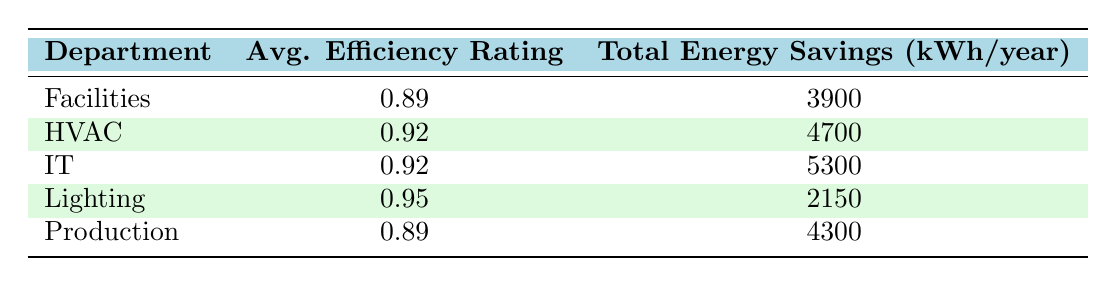What is the average efficiency rating for the HVAC department? According to the table, the average efficiency rating for the HVAC department is 0.92.
Answer: 0.92 Which department has the highest total energy savings? The IT department has the highest total energy savings at 5300 kWh/year.
Answer: IT What is the total energy savings for the Facilities department? The Facilities department has a total energy saving of 3900 kWh/year as stated in the table.
Answer: 3900 Is the average efficiency rating for the Production department greater than 0.90? No, the average efficiency rating for the Production department is 0.89, which is not greater than 0.90.
Answer: No If we combine the total energy savings from the IT and HVAC departments, what is the total? The total energy savings for the IT department is 5300 kWh/year, and for the HVAC department, it is 4700 kWh/year. Adding these together gives us 5300 + 4700 = 10000 kWh/year.
Answer: 10000 What is the average efficiency rating across all departments listed in the table? To find the average efficiency rating, you sum the efficiency ratings for each department (0.85 + 0.92 + 0.95 + 0.88 + 0.97 + 0.93 + 0.89 + 0.91 + 0.87)/9 = 0.90.
Answer: 0.90 Do both the HVAC and Lighting departments have average efficiency ratings greater than 0.90? Yes, both departments have average efficiency ratings of 0.92 and 0.95, respectively, which are greater than 0.90.
Answer: Yes Which department has the lowest average efficiency rating? The Facilities department has the lowest average efficiency rating at 0.89.
Answer: Facilities 